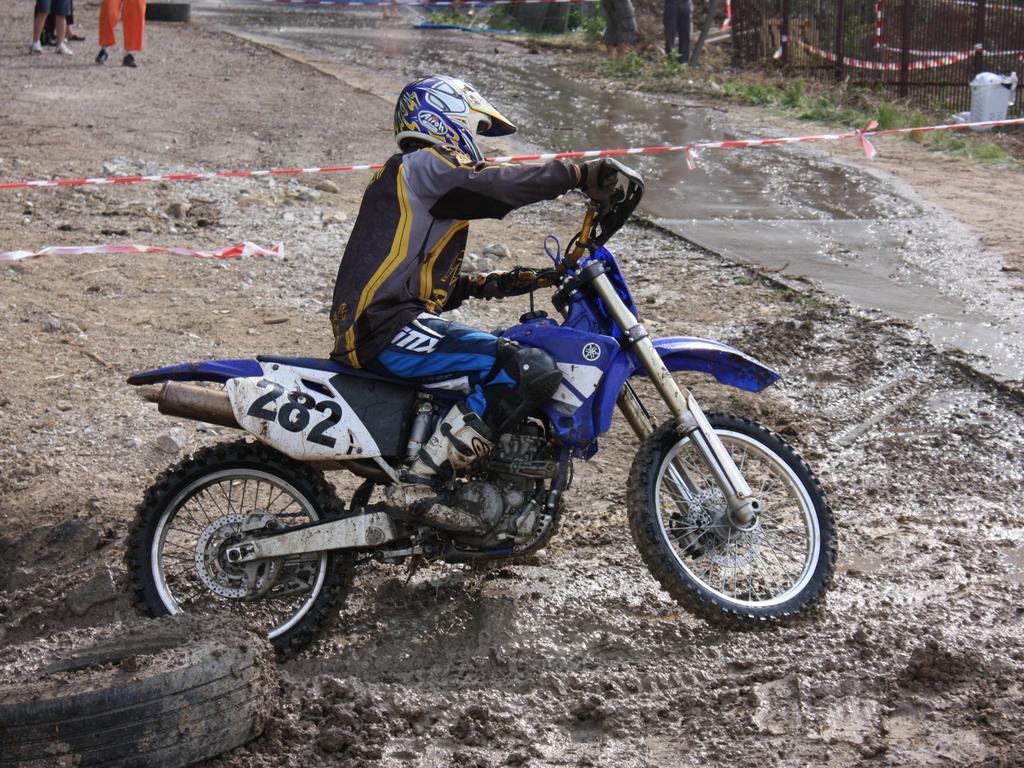In one or two sentences, can you explain what this image depicts? In the picture there is a man riding motorcycle in the sand the sand is very wet and the person is wearing a jacket and helmet,in the left side there are some people standing outside and watching the man. 